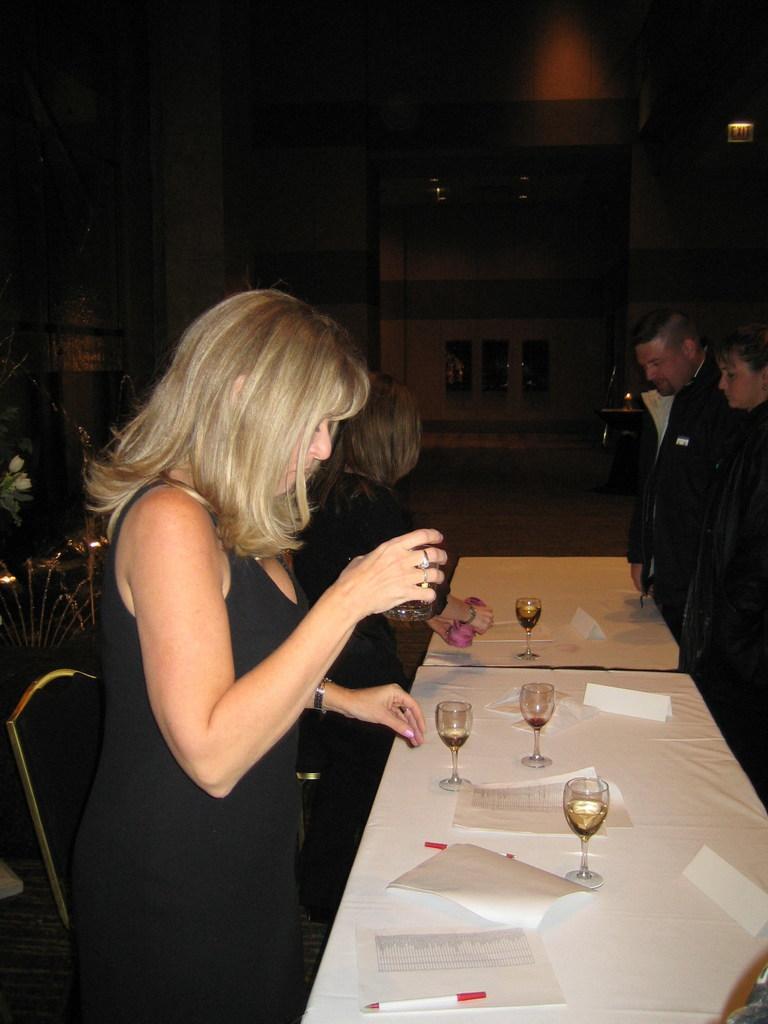Can you describe this image briefly? in the image we can see few persons were standing around the table. On table,we can see glasses,papers and pen. And back we can see wall and few objects around them. 